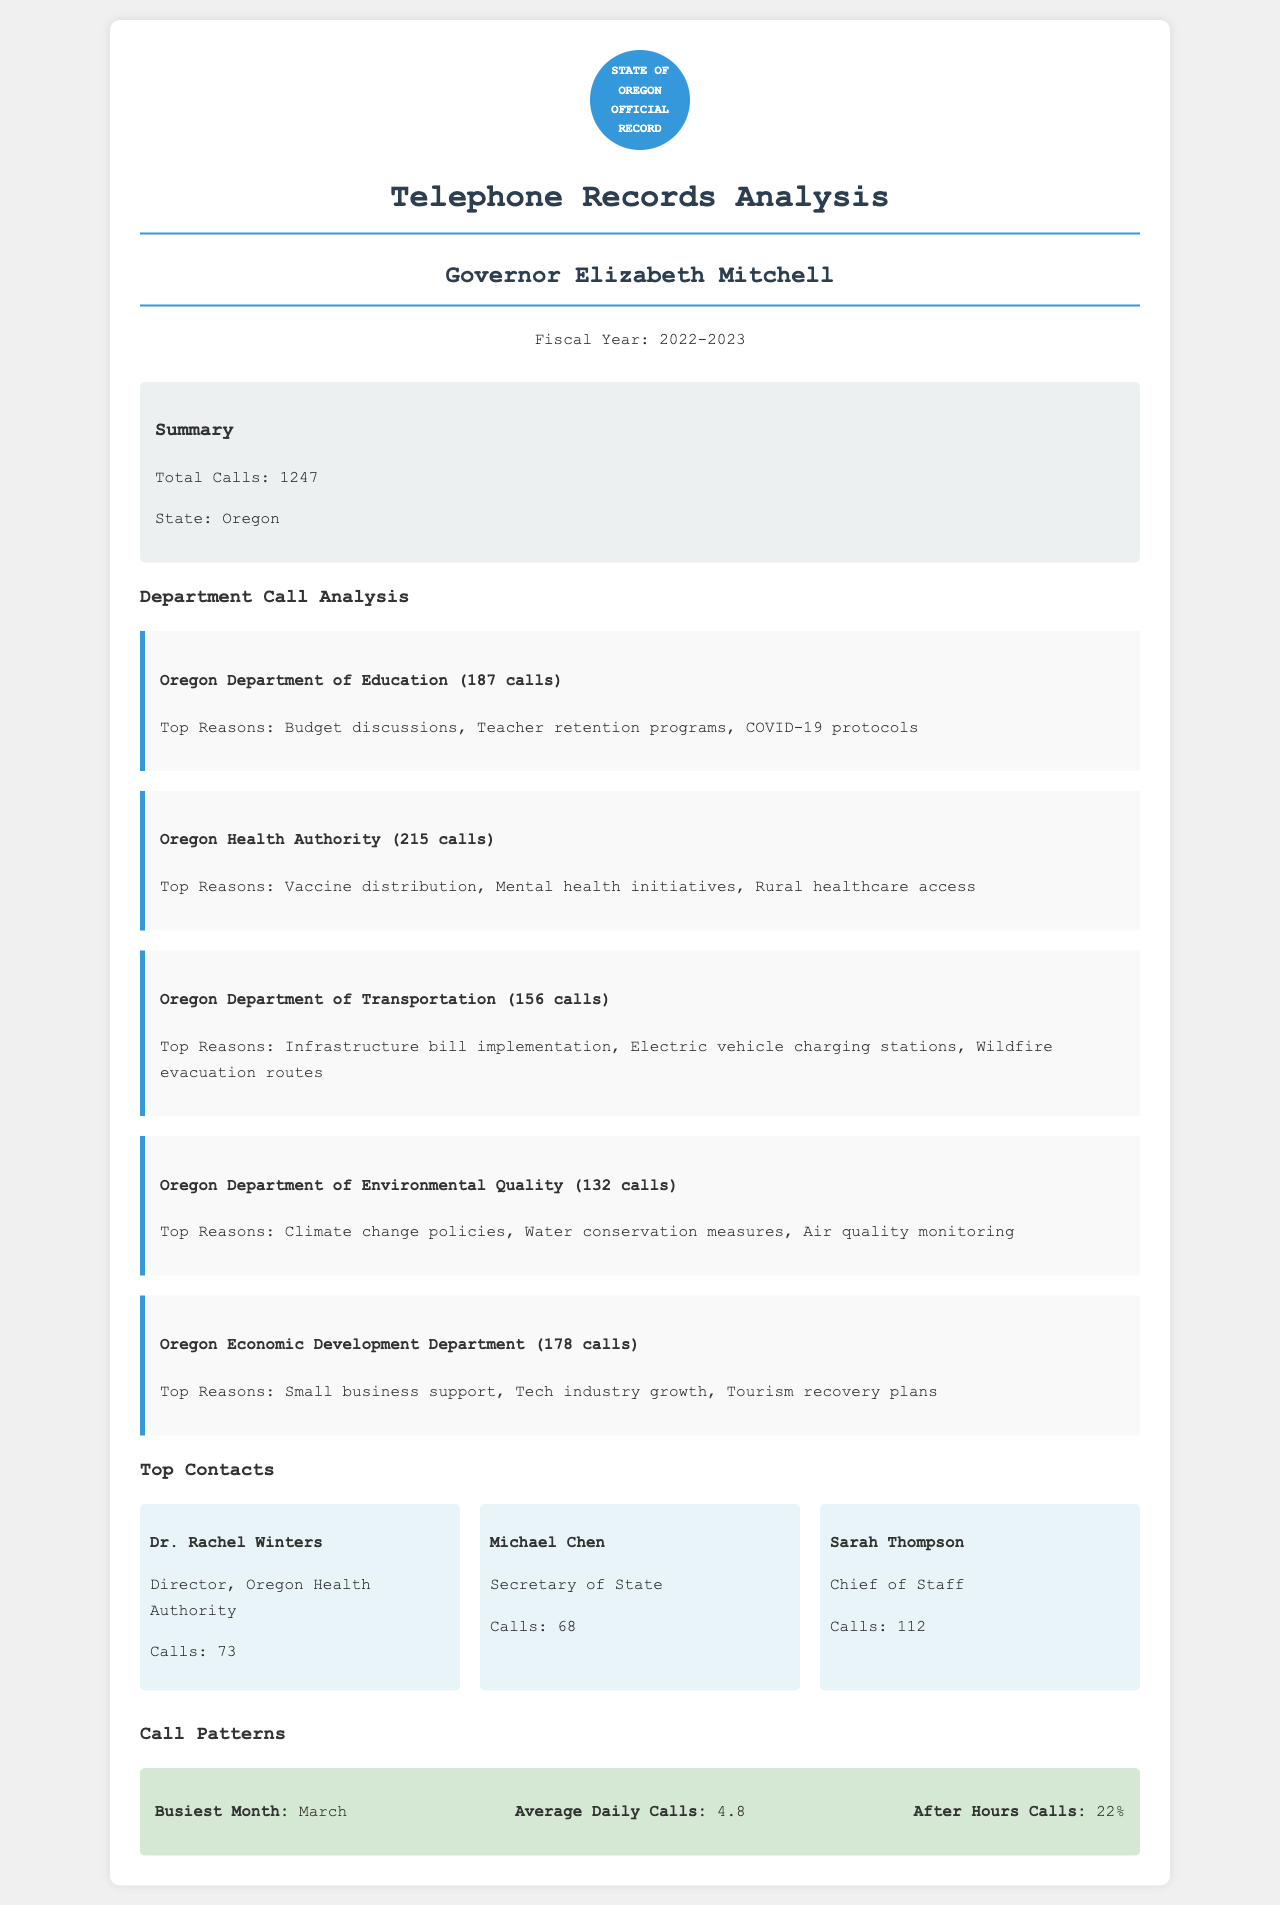What is the total number of calls made by the governor? The total number of calls is stated at the beginning of the document, which is 1247.
Answer: 1247 How many calls were made to the Oregon Health Authority? The number of calls made to the Oregon Health Authority is specified in the department call analysis section, which is 215 calls.
Answer: 215 calls Who is the director of the Oregon Health Authority? The document lists the top contacts, among which Dr. Rachel Winters is the director of the Oregon Health Authority.
Answer: Dr. Rachel Winters What was the busiest month for outgoing calls? The busiest month can be found in the call patterns section, indicating that March had the highest call volume.
Answer: March What percentage of calls were made after hours? The document provides the percentage of after-hours calls, which is presented in the call patterns section as 22%.
Answer: 22% What are the top reasons for calls to the Oregon Department of Education? The document lists the top reasons for calls, including budget discussions, teacher retention programs, and COVID-19 protocols, as noted in the department analysis.
Answer: Budget discussions, Teacher retention programs, COVID-19 protocols How many calls did Sarah Thompson log? The number of calls logged by Sarah Thompson is detailed in the top contacts section, indicating 112 calls.
Answer: 112 calls What was the average daily number of calls? The average daily calls are specified in the call patterns, which states 4.8 calls per day.
Answer: 4.8 